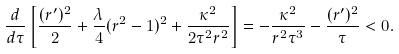<formula> <loc_0><loc_0><loc_500><loc_500>\frac { d } { d \tau } \left [ \frac { ( r ^ { \prime } ) ^ { 2 } } { 2 } + \frac { \lambda } { 4 } ( r ^ { 2 } - 1 ) ^ { 2 } + \frac { \kappa ^ { 2 } } { 2 \tau ^ { 2 } r ^ { 2 } } \right ] = - \frac { \kappa ^ { 2 } } { r ^ { 2 } \tau ^ { 3 } } - \frac { ( r ^ { \prime } ) ^ { 2 } } { \tau } < 0 .</formula> 